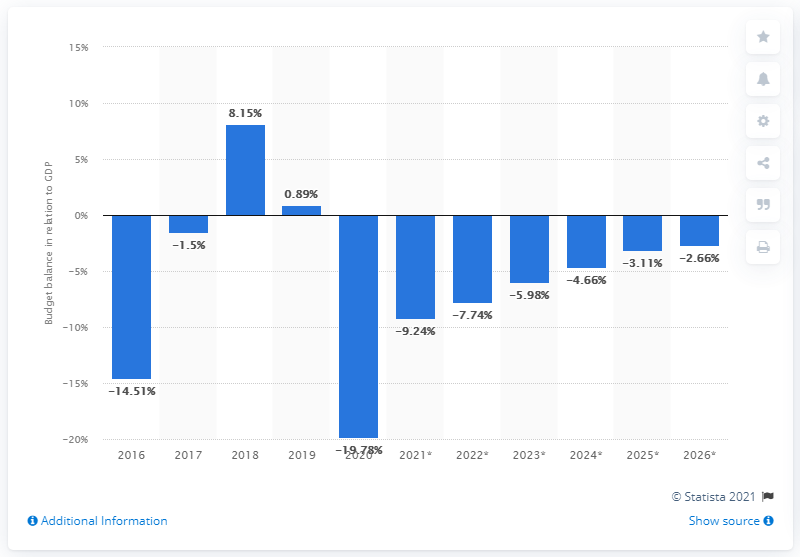Draw attention to some important aspects in this diagram. Iraq's budget balance last achieved parity with its Gross Domestic Product in the year 2020. 